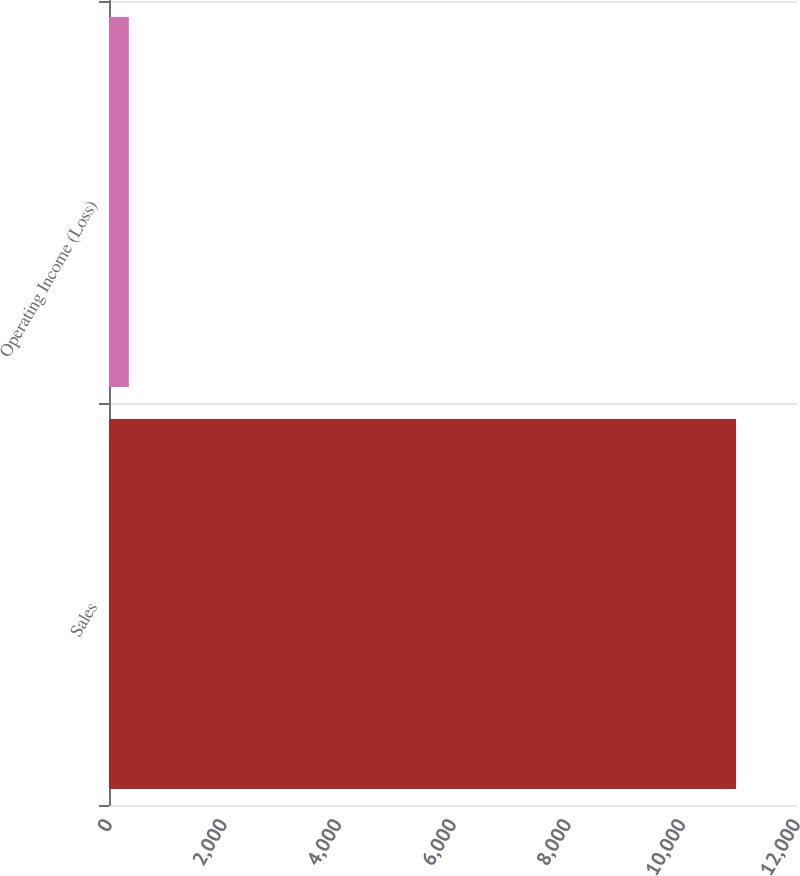Convert chart. <chart><loc_0><loc_0><loc_500><loc_500><bar_chart><fcel>Sales<fcel>Operating Income (Loss)<nl><fcel>10937<fcel>346<nl></chart> 